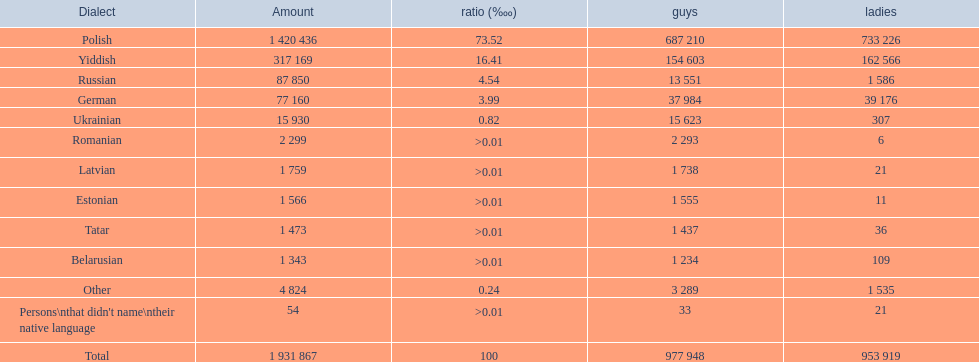What are all of the languages Polish, Yiddish, Russian, German, Ukrainian, Romanian, Latvian, Estonian, Tatar, Belarusian, Other, Persons\nthat didn't name\ntheir native language. What was the percentage of each? 73.52, 16.41, 4.54, 3.99, 0.82, >0.01, >0.01, >0.01, >0.01, >0.01, 0.24, >0.01. Which languages had a >0.01	 percentage? Romanian, Latvian, Estonian, Tatar, Belarusian. And of those, which is listed first? Romanian. 